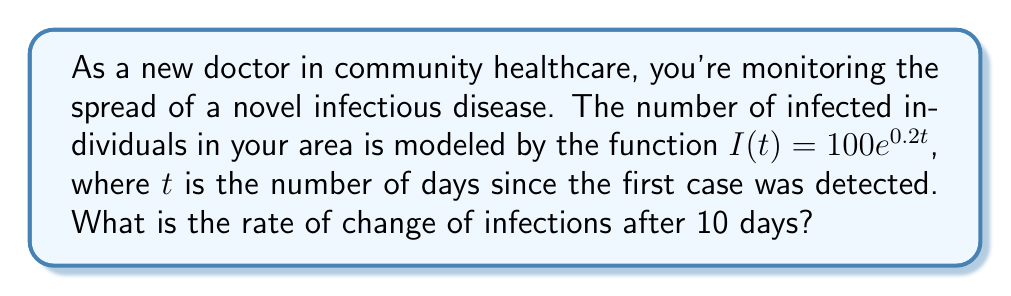Can you answer this question? To find the rate of change of infections after 10 days, we need to differentiate the given function $I(t)$ and then evaluate it at $t=10$. Let's follow these steps:

1) The given function is $I(t) = 100e^{0.2t}$

2) To find the derivative, we use the chain rule:
   $$\frac{dI}{dt} = 100 \cdot \frac{d}{dt}(e^{0.2t})$$
   $$\frac{dI}{dt} = 100 \cdot 0.2e^{0.2t}$$
   $$\frac{dI}{dt} = 20e^{0.2t}$$

3) This derivative represents the rate of change of infections at any time $t$.

4) To find the rate of change after 10 days, we evaluate the derivative at $t=10$:
   $$\frac{dI}{dt}(10) = 20e^{0.2(10)}$$
   $$\frac{dI}{dt}(10) = 20e^2$$
   $$\frac{dI}{dt}(10) = 20 \cdot 7.389 \approx 147.78$$

5) Therefore, after 10 days, the rate of change of infections is approximately 147.78 new cases per day.
Answer: $20e^2$ new cases per day 